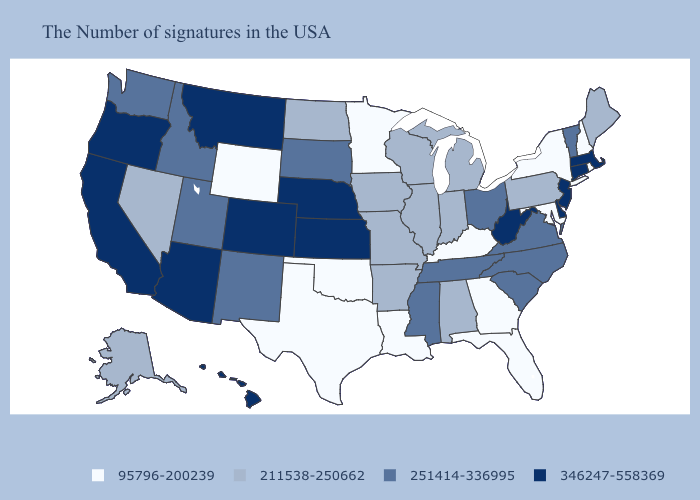Which states hav the highest value in the West?
Quick response, please. Colorado, Montana, Arizona, California, Oregon, Hawaii. Does Nevada have the highest value in the USA?
Write a very short answer. No. What is the highest value in the MidWest ?
Write a very short answer. 346247-558369. Does Iowa have the same value as Georgia?
Be succinct. No. Name the states that have a value in the range 346247-558369?
Quick response, please. Massachusetts, Connecticut, New Jersey, Delaware, West Virginia, Kansas, Nebraska, Colorado, Montana, Arizona, California, Oregon, Hawaii. Which states have the lowest value in the USA?
Be succinct. Rhode Island, New Hampshire, New York, Maryland, Florida, Georgia, Kentucky, Louisiana, Minnesota, Oklahoma, Texas, Wyoming. Name the states that have a value in the range 95796-200239?
Be succinct. Rhode Island, New Hampshire, New York, Maryland, Florida, Georgia, Kentucky, Louisiana, Minnesota, Oklahoma, Texas, Wyoming. What is the lowest value in the MidWest?
Concise answer only. 95796-200239. Name the states that have a value in the range 95796-200239?
Give a very brief answer. Rhode Island, New Hampshire, New York, Maryland, Florida, Georgia, Kentucky, Louisiana, Minnesota, Oklahoma, Texas, Wyoming. Does Florida have the same value as Oregon?
Concise answer only. No. What is the value of Missouri?
Short answer required. 211538-250662. How many symbols are there in the legend?
Short answer required. 4. What is the value of New Jersey?
Quick response, please. 346247-558369. Name the states that have a value in the range 211538-250662?
Answer briefly. Maine, Pennsylvania, Michigan, Indiana, Alabama, Wisconsin, Illinois, Missouri, Arkansas, Iowa, North Dakota, Nevada, Alaska. 